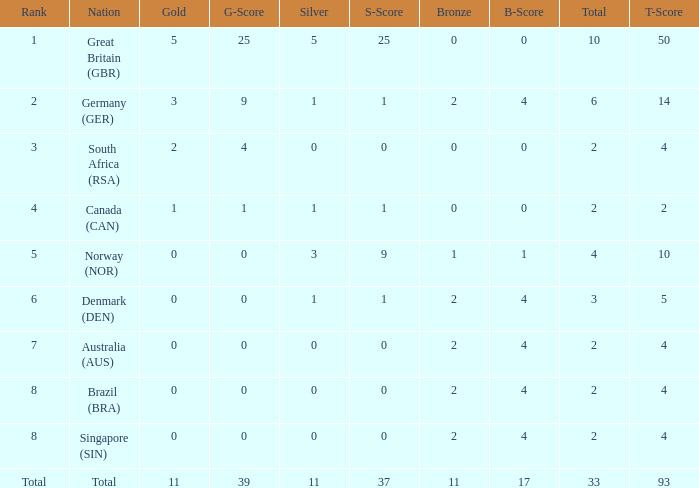What is the least total when the nation is canada (can) and bronze is less than 0? None. 